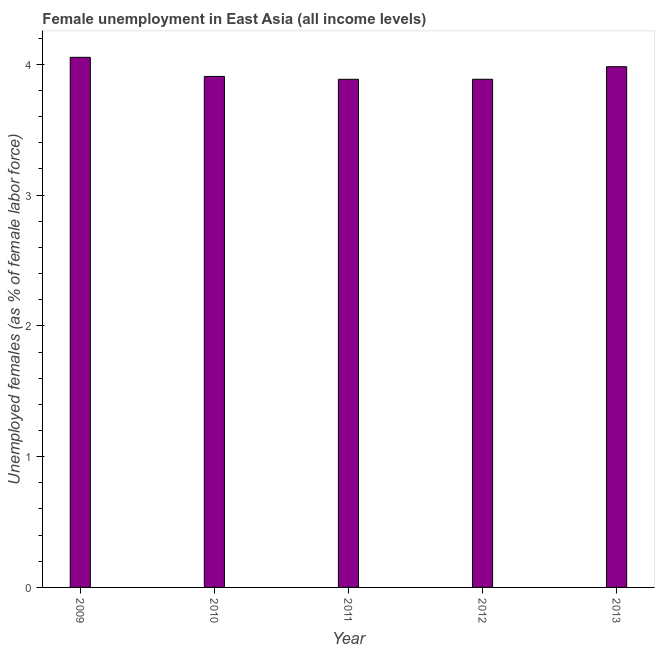What is the title of the graph?
Make the answer very short. Female unemployment in East Asia (all income levels). What is the label or title of the X-axis?
Your answer should be very brief. Year. What is the label or title of the Y-axis?
Your answer should be very brief. Unemployed females (as % of female labor force). What is the unemployed females population in 2011?
Give a very brief answer. 3.89. Across all years, what is the maximum unemployed females population?
Your answer should be compact. 4.05. Across all years, what is the minimum unemployed females population?
Offer a terse response. 3.89. In which year was the unemployed females population maximum?
Your response must be concise. 2009. In which year was the unemployed females population minimum?
Offer a very short reply. 2011. What is the sum of the unemployed females population?
Make the answer very short. 19.71. What is the difference between the unemployed females population in 2009 and 2011?
Provide a short and direct response. 0.17. What is the average unemployed females population per year?
Give a very brief answer. 3.94. What is the median unemployed females population?
Keep it short and to the point. 3.91. Do a majority of the years between 2011 and 2012 (inclusive) have unemployed females population greater than 2 %?
Give a very brief answer. Yes. What is the ratio of the unemployed females population in 2011 to that in 2013?
Make the answer very short. 0.98. Is the unemployed females population in 2010 less than that in 2012?
Your answer should be compact. No. Is the difference between the unemployed females population in 2010 and 2011 greater than the difference between any two years?
Keep it short and to the point. No. What is the difference between the highest and the second highest unemployed females population?
Offer a terse response. 0.07. What is the difference between the highest and the lowest unemployed females population?
Give a very brief answer. 0.17. How many bars are there?
Make the answer very short. 5. Are all the bars in the graph horizontal?
Your answer should be very brief. No. How many years are there in the graph?
Give a very brief answer. 5. What is the difference between two consecutive major ticks on the Y-axis?
Your answer should be compact. 1. What is the Unemployed females (as % of female labor force) of 2009?
Your answer should be very brief. 4.05. What is the Unemployed females (as % of female labor force) in 2010?
Your answer should be very brief. 3.91. What is the Unemployed females (as % of female labor force) of 2011?
Offer a terse response. 3.89. What is the Unemployed females (as % of female labor force) of 2012?
Your answer should be very brief. 3.89. What is the Unemployed females (as % of female labor force) in 2013?
Give a very brief answer. 3.98. What is the difference between the Unemployed females (as % of female labor force) in 2009 and 2010?
Provide a short and direct response. 0.15. What is the difference between the Unemployed females (as % of female labor force) in 2009 and 2011?
Ensure brevity in your answer.  0.17. What is the difference between the Unemployed females (as % of female labor force) in 2009 and 2012?
Give a very brief answer. 0.17. What is the difference between the Unemployed females (as % of female labor force) in 2009 and 2013?
Provide a succinct answer. 0.07. What is the difference between the Unemployed females (as % of female labor force) in 2010 and 2011?
Your answer should be compact. 0.02. What is the difference between the Unemployed females (as % of female labor force) in 2010 and 2012?
Ensure brevity in your answer.  0.02. What is the difference between the Unemployed females (as % of female labor force) in 2010 and 2013?
Make the answer very short. -0.07. What is the difference between the Unemployed females (as % of female labor force) in 2011 and 2012?
Offer a terse response. -0. What is the difference between the Unemployed females (as % of female labor force) in 2011 and 2013?
Your answer should be very brief. -0.1. What is the difference between the Unemployed females (as % of female labor force) in 2012 and 2013?
Provide a succinct answer. -0.1. What is the ratio of the Unemployed females (as % of female labor force) in 2009 to that in 2010?
Offer a very short reply. 1.04. What is the ratio of the Unemployed females (as % of female labor force) in 2009 to that in 2011?
Provide a succinct answer. 1.04. What is the ratio of the Unemployed females (as % of female labor force) in 2009 to that in 2012?
Offer a terse response. 1.04. What is the ratio of the Unemployed females (as % of female labor force) in 2010 to that in 2012?
Ensure brevity in your answer.  1.01. What is the ratio of the Unemployed females (as % of female labor force) in 2011 to that in 2013?
Make the answer very short. 0.98. What is the ratio of the Unemployed females (as % of female labor force) in 2012 to that in 2013?
Your answer should be compact. 0.98. 